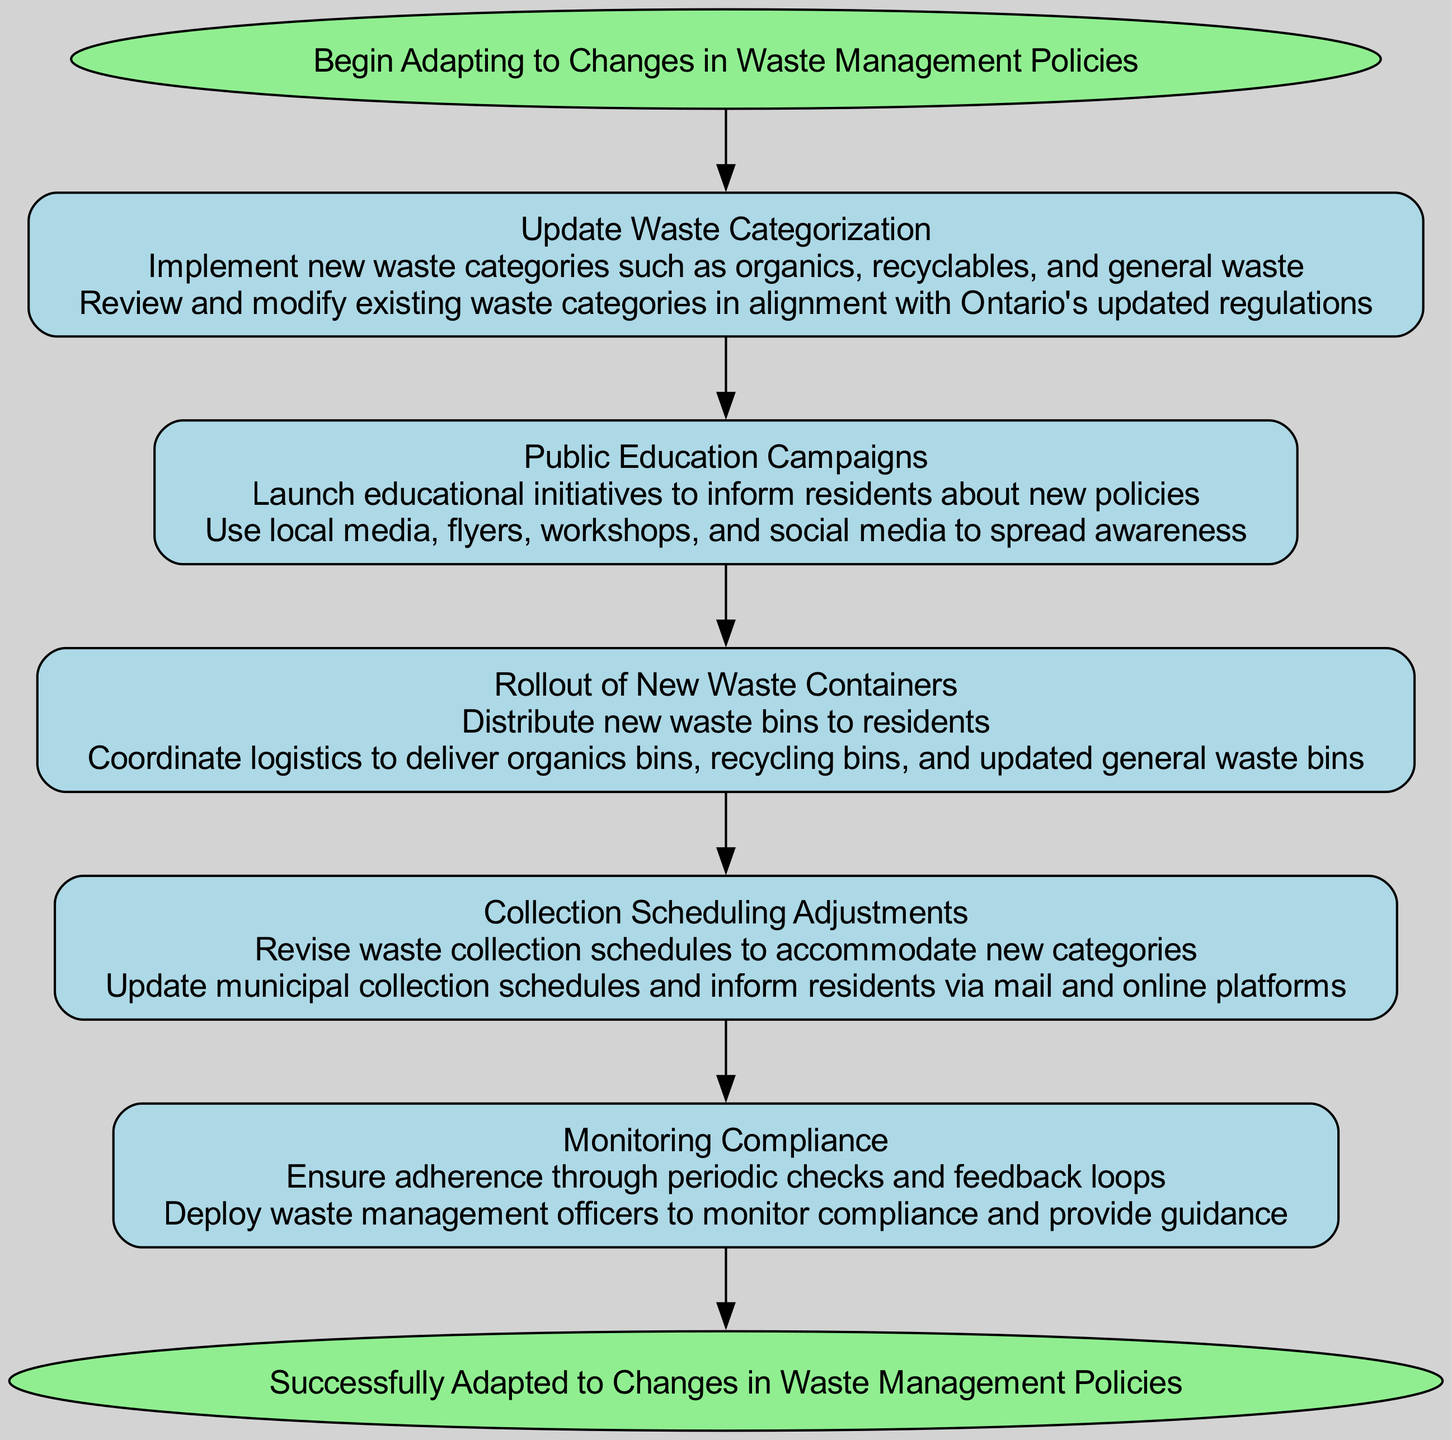What is the starting point of the flowchart? The flowchart begins with the node labeled "Begin Adapting to Changes in Waste Management Policies." This is the entry point of the process, clearly depicted as the starting node.
Answer: Begin Adapting to Changes in Waste Management Policies How many steps are included in the flowchart? The flowchart consists of five steps, each representing a different aspect of adapting to waste management policies. You can count these steps as they are listed sequentially in the diagram.
Answer: 5 What is the last step before reaching the end of the flowchart? The last step before the end of the flowchart is "Monitoring Compliance." It follows the previous step and leads directly to the end node.
Answer: Monitoring Compliance Which node describes the action of distributing new waste bins? The node that describes this action is "Rollout of New Waste Containers." This is explicitly stated in the node's label and emphasizes distribution.
Answer: Rollout of New Waste Containers What is one method used in the public education campaigns? One method used is "Use local media, flyers, workshops, and social media." This is part of the action specified in the "Public Education Campaigns" node.
Answer: Use local media, flyers, workshops, and social media Which step comes immediately after updating waste categorization? After "Update Waste Categorization," the next step is "Public Education Campaigns." This sequence shows the flow of actions taken to adapt to policy changes.
Answer: Public Education Campaigns How does the flowchart end? The flowchart ends with the node labeled "Successfully Adapted to Changes in Waste Management Policies." This indicates the successful completion of the entire process.
Answer: Successfully Adapted to Changes in Waste Management Policies What is the description provided for "Collection Scheduling Adjustments"? The description states, "Revise waste collection schedules to accommodate new categories." This highlights the purpose of the step in the flowchart.
Answer: Revise waste collection schedules to accommodate new categories What is the primary focus of the "Monitoring Compliance" step? The primary focus is to "Ensure adherence through periodic checks and feedback loops." This indicates the need for ongoing oversight in the waste management process.
Answer: Ensure adherence through periodic checks and feedback loops 